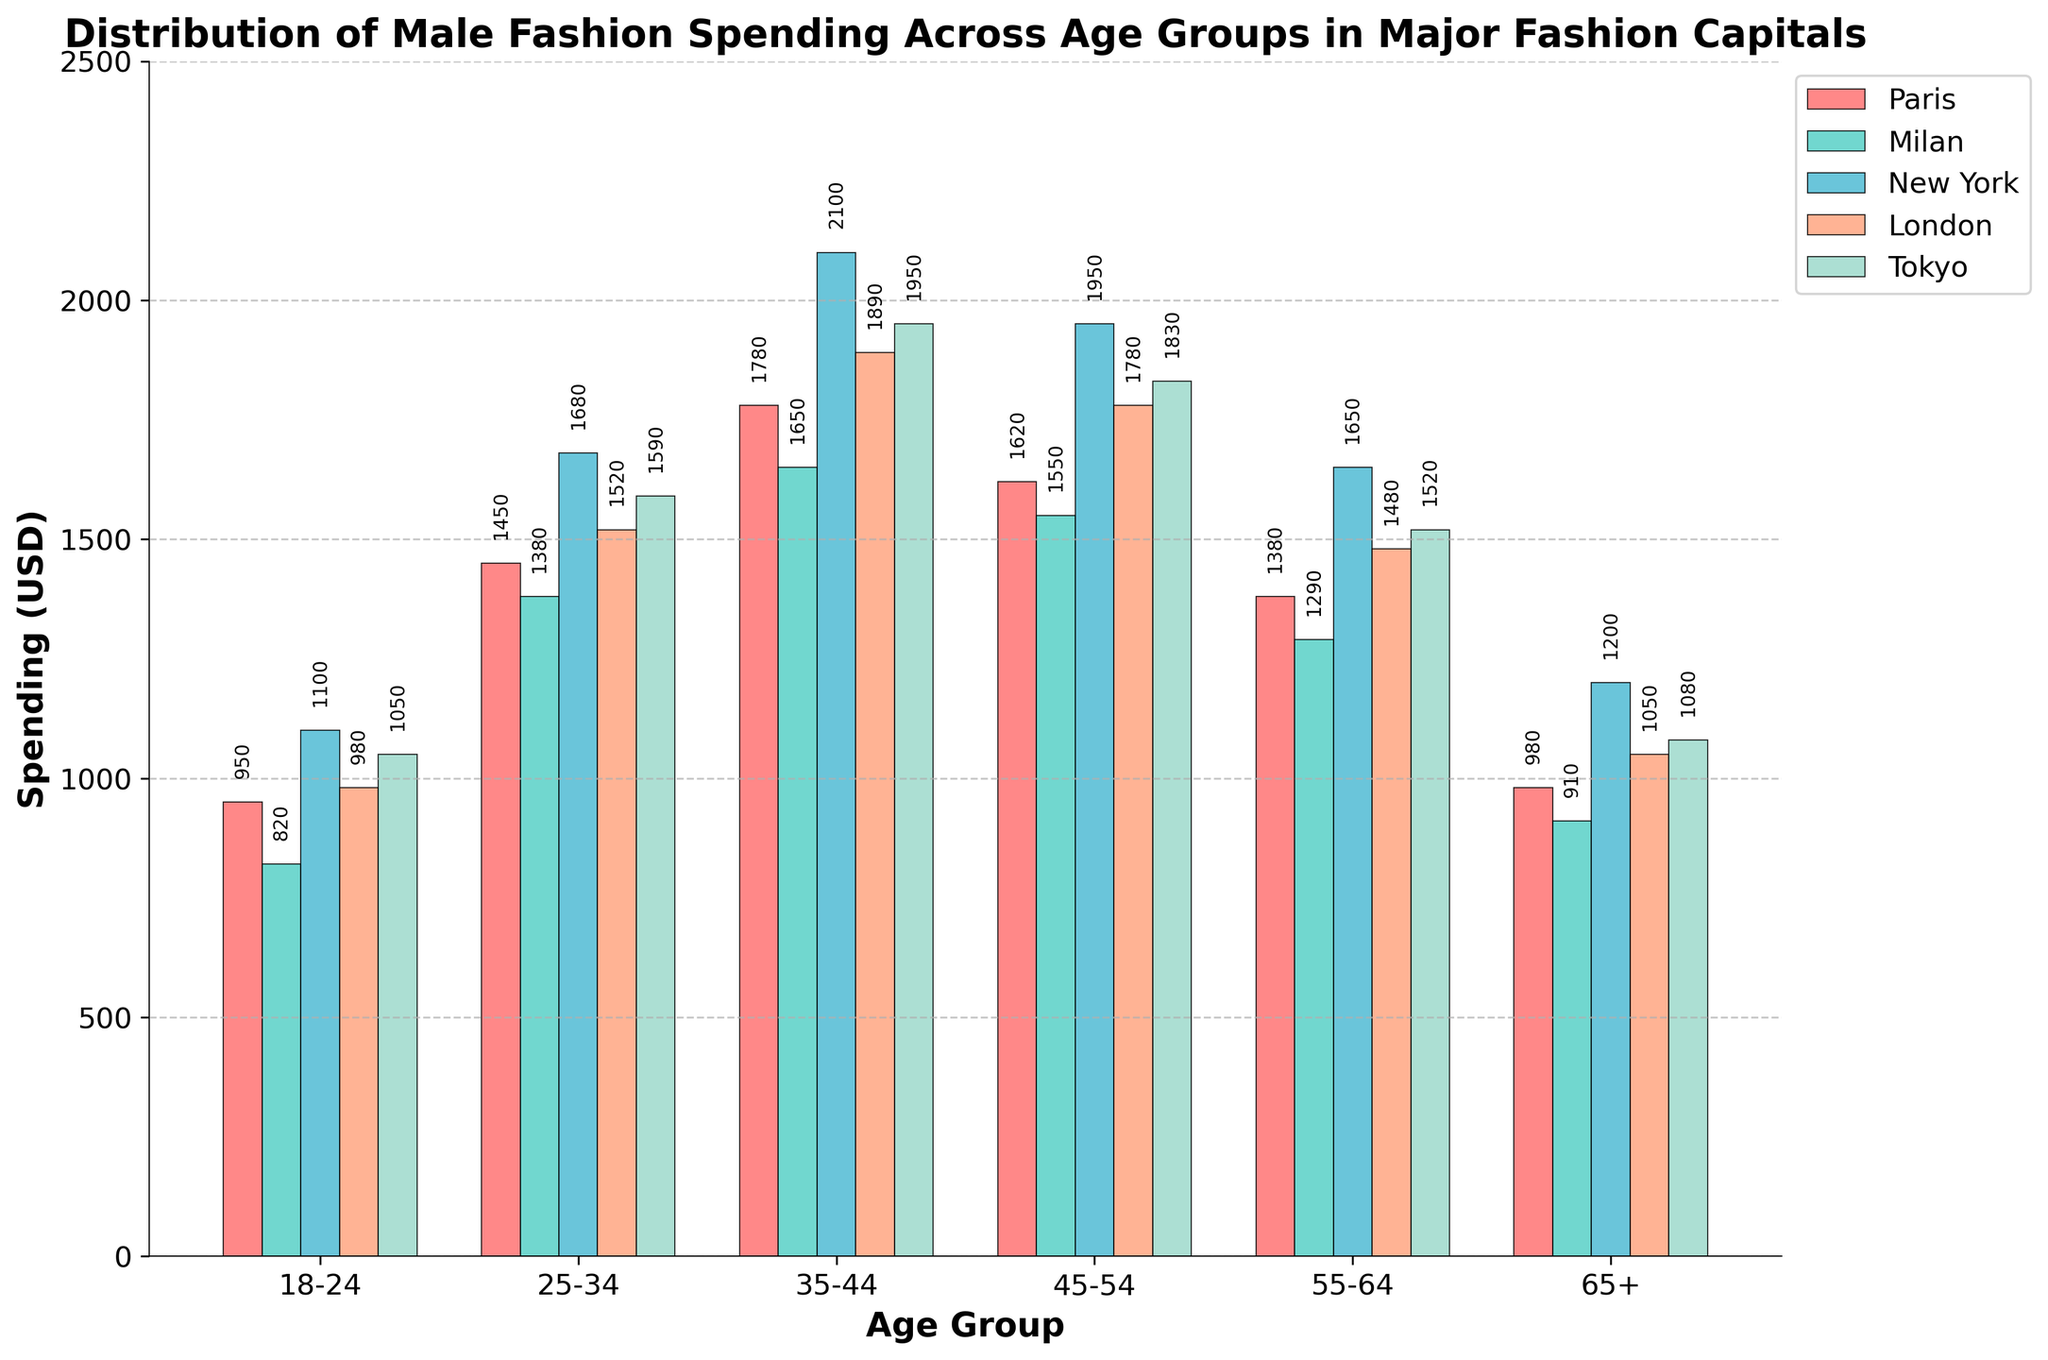What's the age group with the highest spending in New York? Look at the bars corresponding to New York and compare their heights. The age group 35-44 has the highest bar, indicating the highest spending.
Answer: 35-44 Among the 18-24 age group, which city has the lowest spending? Compare the heights of the bars for the 18-24 age group. Milan's bar is the shortest.
Answer: Milan What is the total spending in Paris across all age groups? Sum the values of Paris across all age groups: 950 + 1450 + 1780 + 1620 + 1380 + 980 = 8160.
Answer: 8160 Between Tokyo and Milan, which city has a higher spending in the 55-64 age group, and by how much? Compare the bars for Tokyo and Milan in the 55-64 age group. Tokyo's spending is 1520, and Milan's is 1290. The difference is 1520 - 1290 = 230.
Answer: Tokyo by 230 Which age group has the most consistent spending across all cities? Look at the bars within each age group. The 18-24 age group has bars that are closest in height across all cities.
Answer: 18-24 In the 35-44 age group, list the cities in descending order of spending. Compare the heights of the bars in the 35-44 age group. The order is New York (2100), Tokyo (1950), London (1890), Paris (1780), and Milan (1650).
Answer: New York, Tokyo, London, Paris, Milan Calculate the average spending for the 45-54 age group across all cities. Sum the spending for the 45-54 age group and divide by the number of cities: (1620 + 1550 + 1950 + 1780 + 1830) / 5. The sum is 8730; hence the average is 8730/5.
Answer: 1746 By how much does spending in the 25-34 age group in New York exceed the spending in the 25-34 age group in Milan? Subtract Milan's spending from New York's spending for the 25-34 age group: 1680 - 1380 = 300.
Answer: 300 What is the lowest spending recorded for any city and age group shown in the figure? Look across all the bars to find the smallest value. The lowest spending is for Milan in the 18-24 age group, which is 820.
Answer: 820 Which city shows the sharpest increase in spending from the 18-24 age group to the 35-44 age group? Calculate the increase for each city from the 18-24 to the 35-44 age group. The differences are Paris (1780-950 = 830), Milan (1650-820 = 830), New York (2100-1100 = 1000), London (1890-980 = 910), Tokyo (1950-1050 = 900). The sharpest increase is in New York.
Answer: New York 